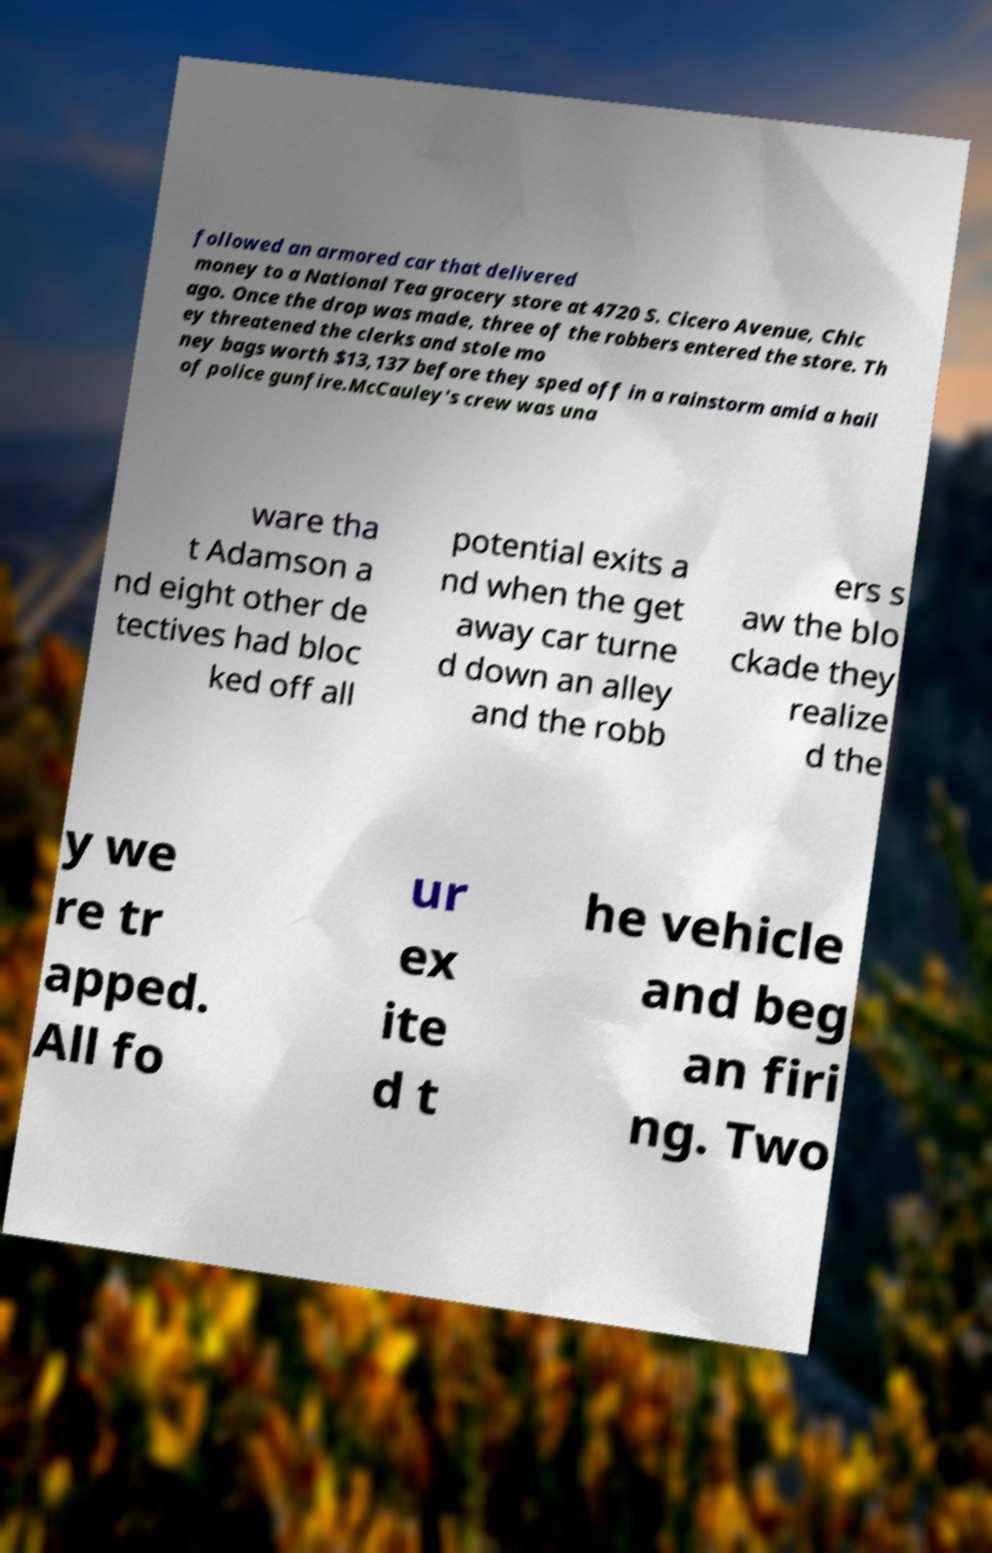I need the written content from this picture converted into text. Can you do that? followed an armored car that delivered money to a National Tea grocery store at 4720 S. Cicero Avenue, Chic ago. Once the drop was made, three of the robbers entered the store. Th ey threatened the clerks and stole mo ney bags worth $13,137 before they sped off in a rainstorm amid a hail of police gunfire.McCauley's crew was una ware tha t Adamson a nd eight other de tectives had bloc ked off all potential exits a nd when the get away car turne d down an alley and the robb ers s aw the blo ckade they realize d the y we re tr apped. All fo ur ex ite d t he vehicle and beg an firi ng. Two 